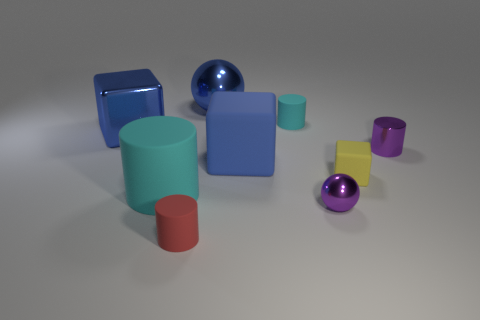There is a large metallic ball; does it have the same color as the rubber cube that is on the left side of the yellow matte object?
Give a very brief answer. Yes. There is a blue cube that is the same material as the yellow block; what size is it?
Provide a short and direct response. Large. Is there a tiny metal thing of the same color as the tiny metal cylinder?
Keep it short and to the point. Yes. What number of things are either things that are right of the big cyan matte object or tiny matte cylinders?
Your answer should be compact. 7. Is the big cylinder made of the same material as the ball behind the tiny block?
Make the answer very short. No. There is a ball that is the same color as the large matte cube; what is its size?
Give a very brief answer. Large. Is there a cylinder made of the same material as the purple sphere?
Offer a terse response. Yes. How many things are either cyan rubber cylinders in front of the blue matte cube or things that are on the left side of the small yellow rubber cube?
Your response must be concise. 7. There is a small yellow rubber object; is it the same shape as the big metallic thing behind the tiny cyan matte object?
Offer a very short reply. No. What number of other things are the same shape as the tiny yellow object?
Ensure brevity in your answer.  2. 